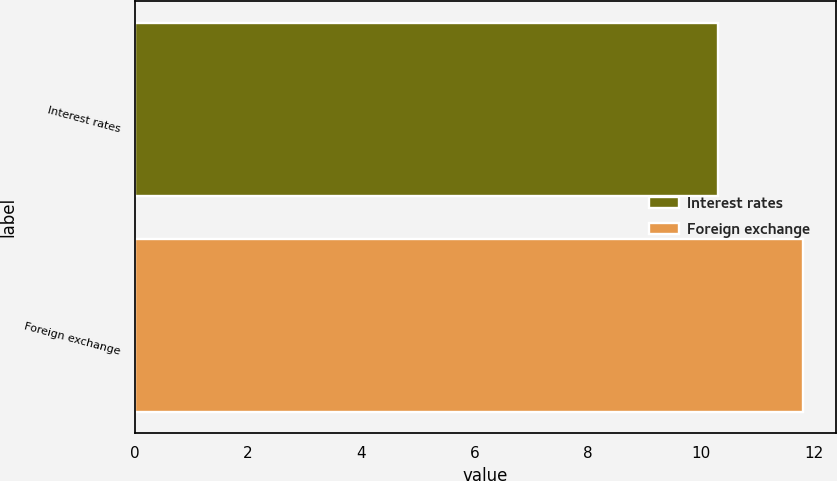Convert chart. <chart><loc_0><loc_0><loc_500><loc_500><bar_chart><fcel>Interest rates<fcel>Foreign exchange<nl><fcel>10.3<fcel>11.8<nl></chart> 